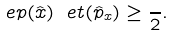Convert formula to latex. <formula><loc_0><loc_0><loc_500><loc_500>\ e p ( \hat { x } ) \ e t ( \hat { p } _ { x } ) \geq \frac { } { 2 } .</formula> 